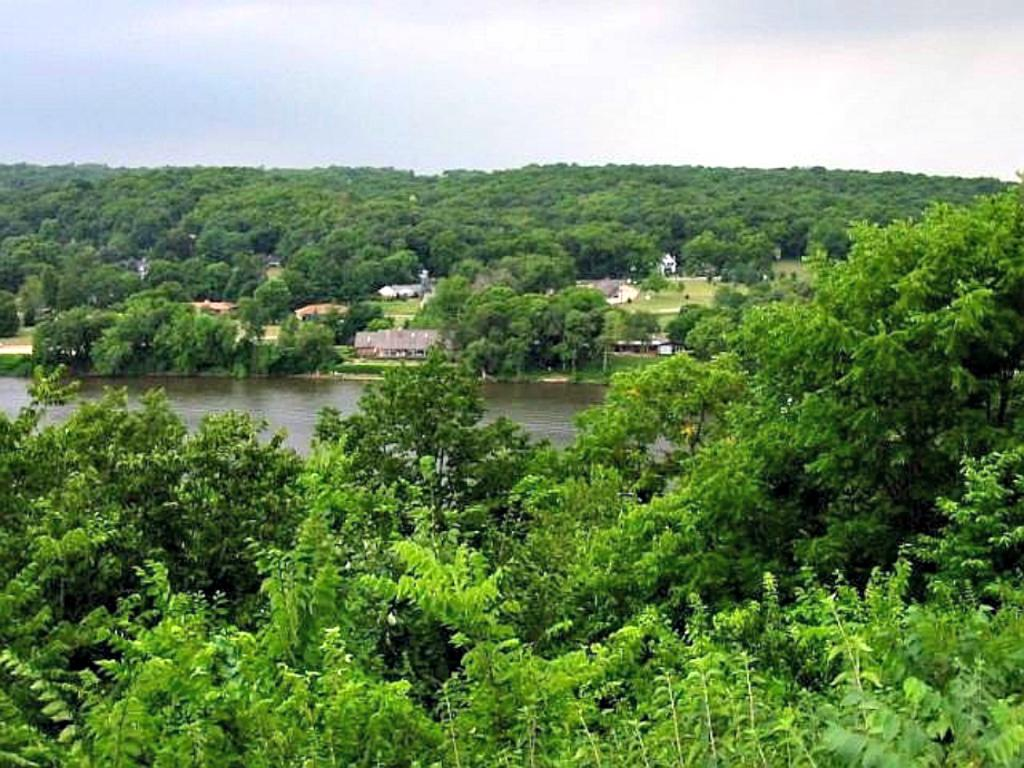What type of natural elements can be seen in the image? There are trees in the image. What type of man-made structures are present in the image? There are buildings in the image. What can be seen in the sky in the image? There are clouds in the image. What is visible in the background of the image? The sky is visible in the image. What is located in the center of the image? There is water in the center of the image. How many maids are present in the image? There are no maids present in the image. What type of drainage system can be seen in the image? There is no drainage system visible in the image. 